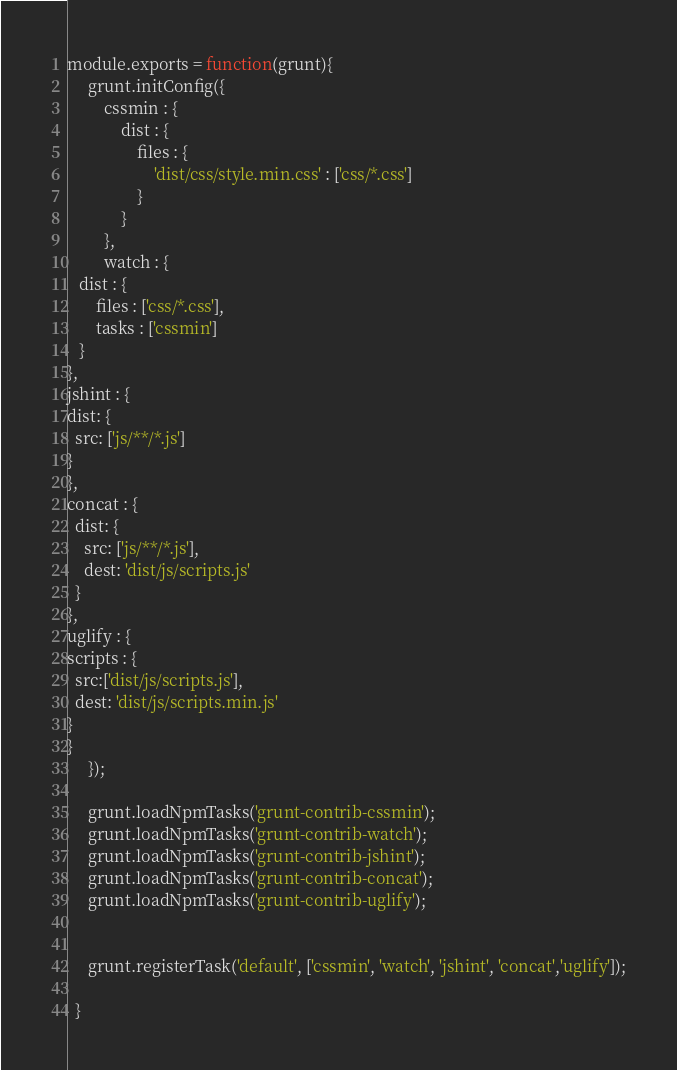Convert code to text. <code><loc_0><loc_0><loc_500><loc_500><_JavaScript_>module.exports = function(grunt){
     grunt.initConfig({
         cssmin : {
             dist : {
                 files : {
                     'dist/css/style.min.css' : ['css/*.css']                    
                 }
             }
         },
         watch : {
   dist : {
       files : ['css/*.css'],
       tasks : ['cssmin']
   }
},
jshint : {
dist: {
  src: ['js/**/*.js']
}
},
concat : {
  dist: {
    src: ['js/**/*.js'],
    dest: 'dist/js/scripts.js'
  }
},
uglify : {
scripts : {
  src:['dist/js/scripts.js'],
  dest: 'dist/js/scripts.min.js'
}
}
     });
    
     grunt.loadNpmTasks('grunt-contrib-cssmin');
     grunt.loadNpmTasks('grunt-contrib-watch');
     grunt.loadNpmTasks('grunt-contrib-jshint');
     grunt.loadNpmTasks('grunt-contrib-concat');
     grunt.loadNpmTasks('grunt-contrib-uglify');


     grunt.registerTask('default', ['cssmin', 'watch', 'jshint', 'concat','uglify']);
     
  }</code> 